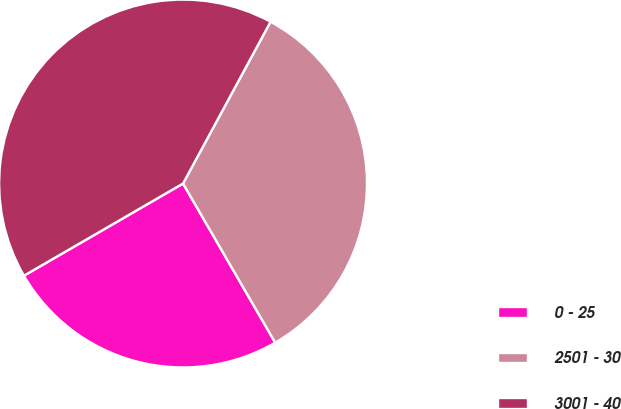<chart> <loc_0><loc_0><loc_500><loc_500><pie_chart><fcel>0 - 25<fcel>2501 - 30<fcel>3001 - 40<nl><fcel>25.0%<fcel>33.75%<fcel>41.25%<nl></chart> 